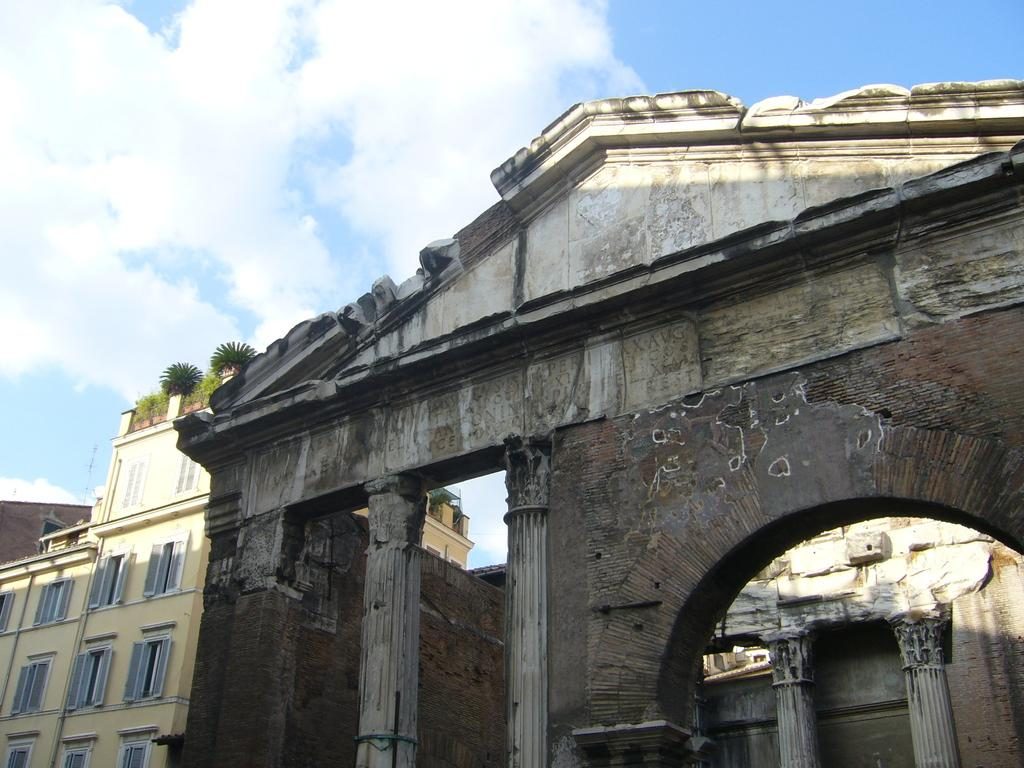What is the condition of the sky in the image? The sky is cloudy in the image. What type of structures can be seen in the image? There are buildings and pillars in the image. What other elements are present in the image? There are plants and windows in the image. Can you tell me what the person is reading in the image? There is no person present in the image, so it is not possible to determine what they might be reading. 